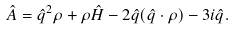Convert formula to latex. <formula><loc_0><loc_0><loc_500><loc_500>\hat { A } = \hat { q } ^ { 2 } \rho + \rho \hat { H } - 2 \hat { q } ( \hat { q } \cdot \rho ) - 3 i \hat { q } .</formula> 